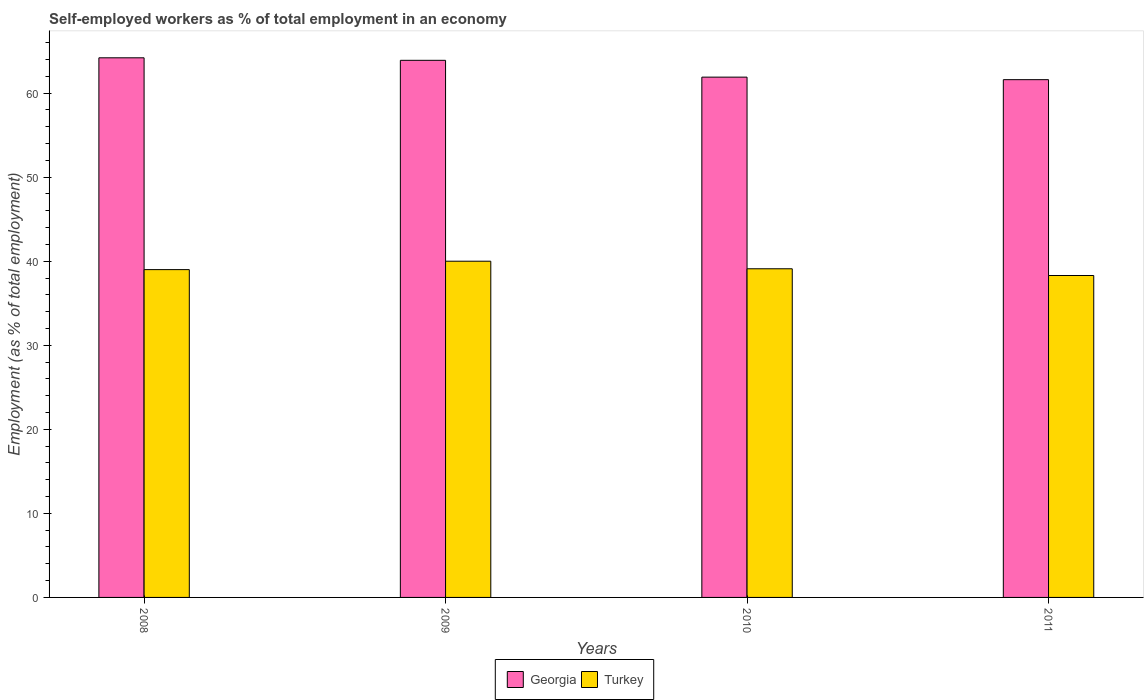How many groups of bars are there?
Give a very brief answer. 4. Are the number of bars on each tick of the X-axis equal?
Your response must be concise. Yes. How many bars are there on the 1st tick from the left?
Your response must be concise. 2. In how many cases, is the number of bars for a given year not equal to the number of legend labels?
Provide a short and direct response. 0. What is the percentage of self-employed workers in Georgia in 2011?
Offer a terse response. 61.6. Across all years, what is the maximum percentage of self-employed workers in Georgia?
Ensure brevity in your answer.  64.2. Across all years, what is the minimum percentage of self-employed workers in Georgia?
Keep it short and to the point. 61.6. In which year was the percentage of self-employed workers in Georgia minimum?
Provide a short and direct response. 2011. What is the total percentage of self-employed workers in Turkey in the graph?
Your answer should be very brief. 156.4. What is the difference between the percentage of self-employed workers in Georgia in 2008 and that in 2009?
Your answer should be very brief. 0.3. What is the difference between the percentage of self-employed workers in Turkey in 2008 and the percentage of self-employed workers in Georgia in 2010?
Provide a succinct answer. -22.9. What is the average percentage of self-employed workers in Georgia per year?
Give a very brief answer. 62.9. In the year 2011, what is the difference between the percentage of self-employed workers in Georgia and percentage of self-employed workers in Turkey?
Ensure brevity in your answer.  23.3. What is the ratio of the percentage of self-employed workers in Turkey in 2009 to that in 2010?
Give a very brief answer. 1.02. Is the difference between the percentage of self-employed workers in Georgia in 2008 and 2011 greater than the difference between the percentage of self-employed workers in Turkey in 2008 and 2011?
Provide a succinct answer. Yes. What is the difference between the highest and the second highest percentage of self-employed workers in Georgia?
Offer a terse response. 0.3. What is the difference between the highest and the lowest percentage of self-employed workers in Turkey?
Your answer should be compact. 1.7. What does the 1st bar from the left in 2008 represents?
Your answer should be compact. Georgia. What does the 2nd bar from the right in 2011 represents?
Your answer should be compact. Georgia. How many bars are there?
Your answer should be very brief. 8. Are the values on the major ticks of Y-axis written in scientific E-notation?
Ensure brevity in your answer.  No. Does the graph contain grids?
Your response must be concise. No. How many legend labels are there?
Provide a short and direct response. 2. How are the legend labels stacked?
Make the answer very short. Horizontal. What is the title of the graph?
Make the answer very short. Self-employed workers as % of total employment in an economy. What is the label or title of the Y-axis?
Provide a short and direct response. Employment (as % of total employment). What is the Employment (as % of total employment) in Georgia in 2008?
Offer a very short reply. 64.2. What is the Employment (as % of total employment) in Turkey in 2008?
Your response must be concise. 39. What is the Employment (as % of total employment) in Georgia in 2009?
Offer a very short reply. 63.9. What is the Employment (as % of total employment) in Georgia in 2010?
Your answer should be compact. 61.9. What is the Employment (as % of total employment) of Turkey in 2010?
Offer a terse response. 39.1. What is the Employment (as % of total employment) in Georgia in 2011?
Your response must be concise. 61.6. What is the Employment (as % of total employment) in Turkey in 2011?
Give a very brief answer. 38.3. Across all years, what is the maximum Employment (as % of total employment) of Georgia?
Give a very brief answer. 64.2. Across all years, what is the minimum Employment (as % of total employment) in Georgia?
Make the answer very short. 61.6. Across all years, what is the minimum Employment (as % of total employment) in Turkey?
Provide a succinct answer. 38.3. What is the total Employment (as % of total employment) of Georgia in the graph?
Offer a terse response. 251.6. What is the total Employment (as % of total employment) in Turkey in the graph?
Make the answer very short. 156.4. What is the difference between the Employment (as % of total employment) in Georgia in 2008 and that in 2010?
Keep it short and to the point. 2.3. What is the difference between the Employment (as % of total employment) of Turkey in 2008 and that in 2010?
Provide a short and direct response. -0.1. What is the difference between the Employment (as % of total employment) in Georgia in 2008 and that in 2011?
Make the answer very short. 2.6. What is the difference between the Employment (as % of total employment) in Turkey in 2008 and that in 2011?
Make the answer very short. 0.7. What is the difference between the Employment (as % of total employment) in Georgia in 2009 and that in 2010?
Make the answer very short. 2. What is the difference between the Employment (as % of total employment) in Georgia in 2009 and that in 2011?
Give a very brief answer. 2.3. What is the difference between the Employment (as % of total employment) in Turkey in 2009 and that in 2011?
Your answer should be very brief. 1.7. What is the difference between the Employment (as % of total employment) of Georgia in 2010 and that in 2011?
Your response must be concise. 0.3. What is the difference between the Employment (as % of total employment) of Turkey in 2010 and that in 2011?
Your response must be concise. 0.8. What is the difference between the Employment (as % of total employment) in Georgia in 2008 and the Employment (as % of total employment) in Turkey in 2009?
Keep it short and to the point. 24.2. What is the difference between the Employment (as % of total employment) in Georgia in 2008 and the Employment (as % of total employment) in Turkey in 2010?
Your answer should be compact. 25.1. What is the difference between the Employment (as % of total employment) in Georgia in 2008 and the Employment (as % of total employment) in Turkey in 2011?
Make the answer very short. 25.9. What is the difference between the Employment (as % of total employment) of Georgia in 2009 and the Employment (as % of total employment) of Turkey in 2010?
Keep it short and to the point. 24.8. What is the difference between the Employment (as % of total employment) in Georgia in 2009 and the Employment (as % of total employment) in Turkey in 2011?
Make the answer very short. 25.6. What is the difference between the Employment (as % of total employment) in Georgia in 2010 and the Employment (as % of total employment) in Turkey in 2011?
Make the answer very short. 23.6. What is the average Employment (as % of total employment) of Georgia per year?
Provide a succinct answer. 62.9. What is the average Employment (as % of total employment) in Turkey per year?
Your response must be concise. 39.1. In the year 2008, what is the difference between the Employment (as % of total employment) in Georgia and Employment (as % of total employment) in Turkey?
Your response must be concise. 25.2. In the year 2009, what is the difference between the Employment (as % of total employment) in Georgia and Employment (as % of total employment) in Turkey?
Your answer should be compact. 23.9. In the year 2010, what is the difference between the Employment (as % of total employment) of Georgia and Employment (as % of total employment) of Turkey?
Your answer should be very brief. 22.8. In the year 2011, what is the difference between the Employment (as % of total employment) in Georgia and Employment (as % of total employment) in Turkey?
Give a very brief answer. 23.3. What is the ratio of the Employment (as % of total employment) in Georgia in 2008 to that in 2010?
Your response must be concise. 1.04. What is the ratio of the Employment (as % of total employment) in Georgia in 2008 to that in 2011?
Keep it short and to the point. 1.04. What is the ratio of the Employment (as % of total employment) in Turkey in 2008 to that in 2011?
Your answer should be very brief. 1.02. What is the ratio of the Employment (as % of total employment) in Georgia in 2009 to that in 2010?
Make the answer very short. 1.03. What is the ratio of the Employment (as % of total employment) in Georgia in 2009 to that in 2011?
Your response must be concise. 1.04. What is the ratio of the Employment (as % of total employment) in Turkey in 2009 to that in 2011?
Your answer should be very brief. 1.04. What is the ratio of the Employment (as % of total employment) of Georgia in 2010 to that in 2011?
Your answer should be compact. 1. What is the ratio of the Employment (as % of total employment) in Turkey in 2010 to that in 2011?
Give a very brief answer. 1.02. What is the difference between the highest and the second highest Employment (as % of total employment) of Georgia?
Offer a terse response. 0.3. What is the difference between the highest and the second highest Employment (as % of total employment) of Turkey?
Provide a short and direct response. 0.9. What is the difference between the highest and the lowest Employment (as % of total employment) in Georgia?
Offer a terse response. 2.6. What is the difference between the highest and the lowest Employment (as % of total employment) in Turkey?
Your answer should be compact. 1.7. 